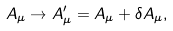<formula> <loc_0><loc_0><loc_500><loc_500>A _ { \mu } \rightarrow A _ { \mu } ^ { \prime } = A _ { \mu } + \delta A _ { \mu } ,</formula> 